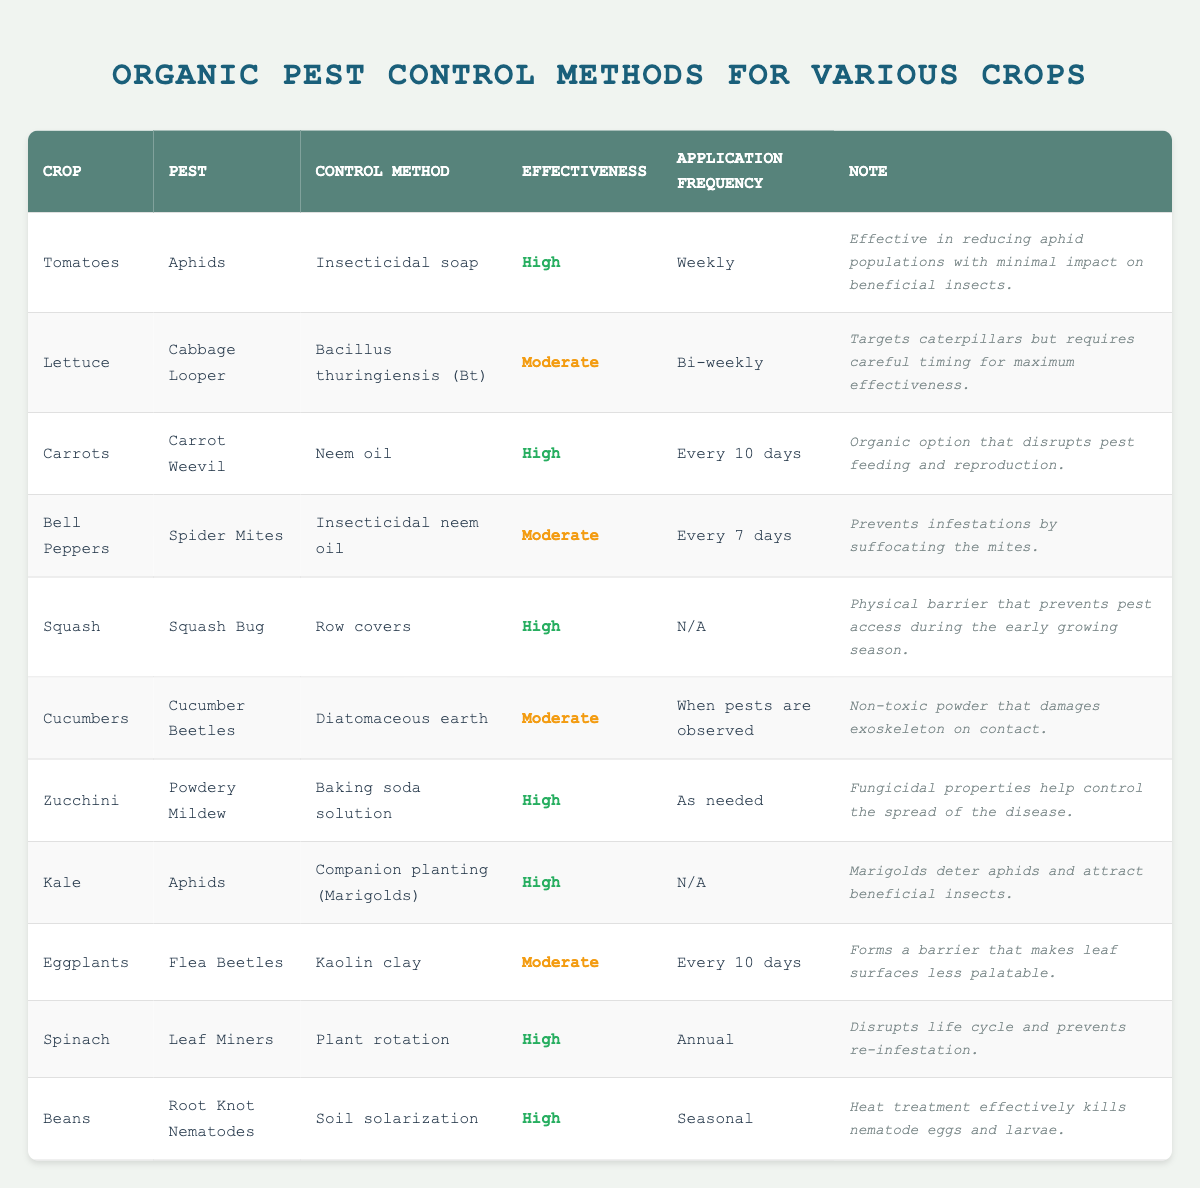What pest control method is used for tomatoes? The table lists "Insecticidal soap" as the pest control method for tomatoes.
Answer: Insecticidal soap How often should neem oil be applied for carrot weevils? The application frequency for neem oil to control carrot weevils is noted as "Every 10 days."
Answer: Every 10 days Is the effectiveness of diatomaceous earth high for cucumber beetles? The effectiveness of diatomaceous earth for cucumber beetles is categorized as "Moderate," not high.
Answer: No Which crop has a pest control method with no specified application frequency? The crops of "Squash" and "Kale" have pest control methods (Row covers and Companion planting with Marigolds) that do not specify any application frequency (N/A).
Answer: Squash and Kale What is the most effective method for controlling root knot nematodes? According to the table, the most effective method listed for root knot nematodes is "Soil solarization," with a high effectiveness rating.
Answer: Soil solarization How does the effectiveness of insecticidal neem oil compare to kaolin clay? Insecticidal neem oil has a moderate effectiveness rating, while kaolin clay also has a moderate effectiveness rating. Therefore, both have the same level of effectiveness.
Answer: They are the same (moderate) For which crop is baking soda solution recommended? The table shows that a baking soda solution is recommended for controlling powdery mildew on "Zucchini."
Answer: Zucchini What pest control method is used for spinach, and how effective is it? The method for spinach is "Plant rotation," and it is rated as "High" in effectiveness according to the table.
Answer: Plant rotation; High Which pest control methods are effective for aphids? The table lists three methods that are effective for aphids: "Insecticidal soap" for tomatoes, "Companion planting (Marigolds)" for kale, and there are no other effective methods listed for other crops.
Answer: Insecticidal soap; Companion planting (Marigolds) What pest control method does not require regular application and what crop is it associated with? The pest control method that does not require regular application is "Row covers," associated with the crop "Squash."
Answer: Row covers; Squash 